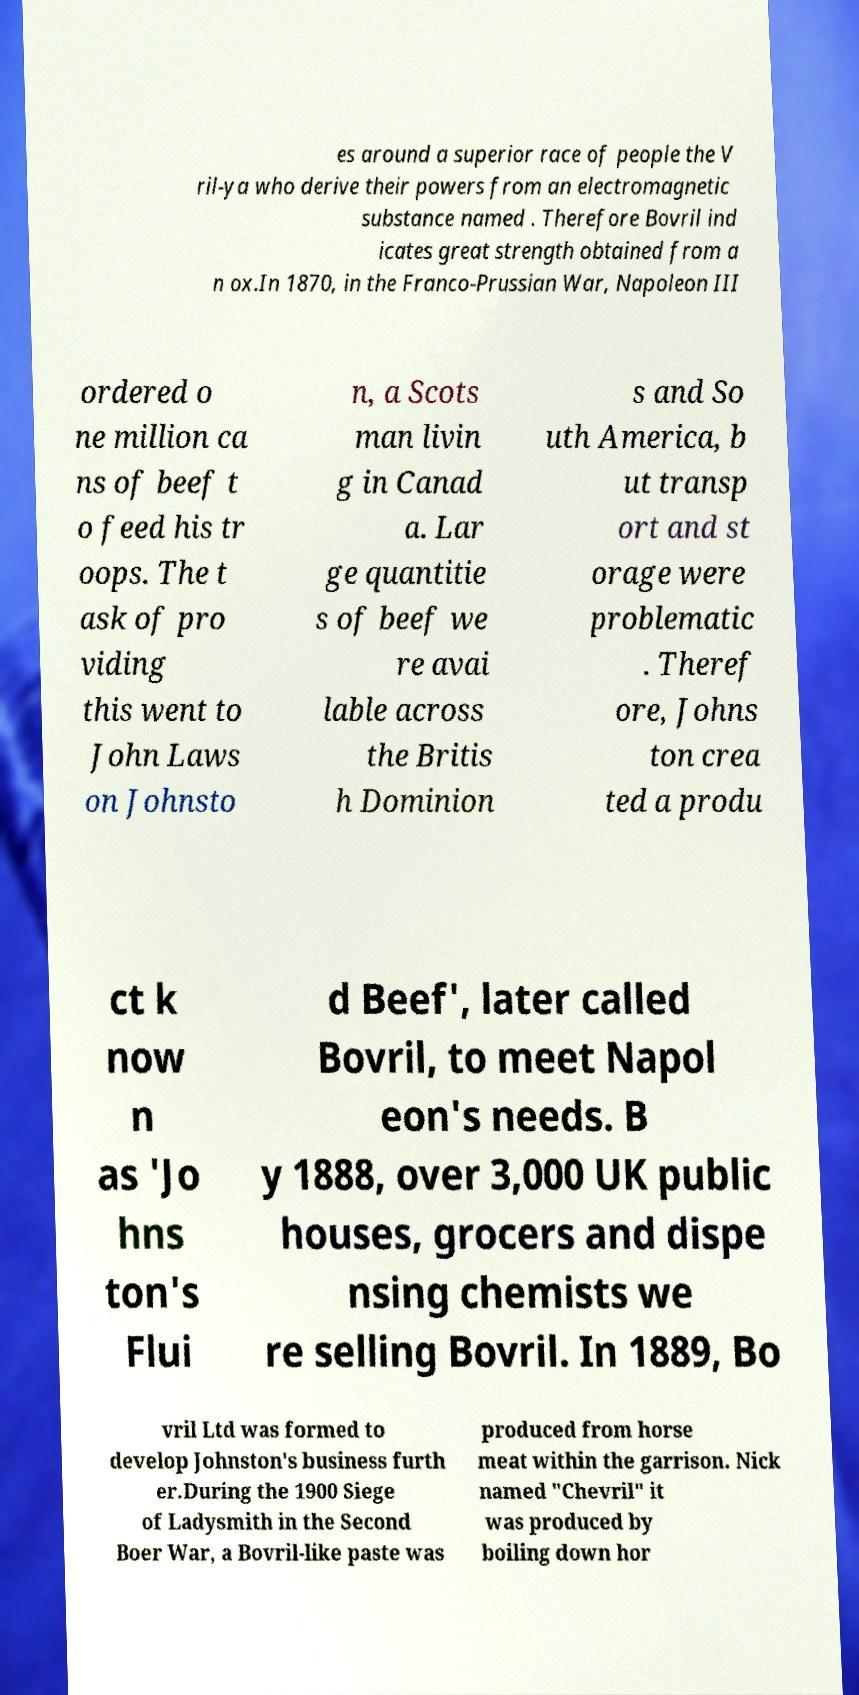Please read and relay the text visible in this image. What does it say? es around a superior race of people the V ril-ya who derive their powers from an electromagnetic substance named . Therefore Bovril ind icates great strength obtained from a n ox.In 1870, in the Franco-Prussian War, Napoleon III ordered o ne million ca ns of beef t o feed his tr oops. The t ask of pro viding this went to John Laws on Johnsto n, a Scots man livin g in Canad a. Lar ge quantitie s of beef we re avai lable across the Britis h Dominion s and So uth America, b ut transp ort and st orage were problematic . Theref ore, Johns ton crea ted a produ ct k now n as 'Jo hns ton's Flui d Beef', later called Bovril, to meet Napol eon's needs. B y 1888, over 3,000 UK public houses, grocers and dispe nsing chemists we re selling Bovril. In 1889, Bo vril Ltd was formed to develop Johnston's business furth er.During the 1900 Siege of Ladysmith in the Second Boer War, a Bovril-like paste was produced from horse meat within the garrison. Nick named "Chevril" it was produced by boiling down hor 